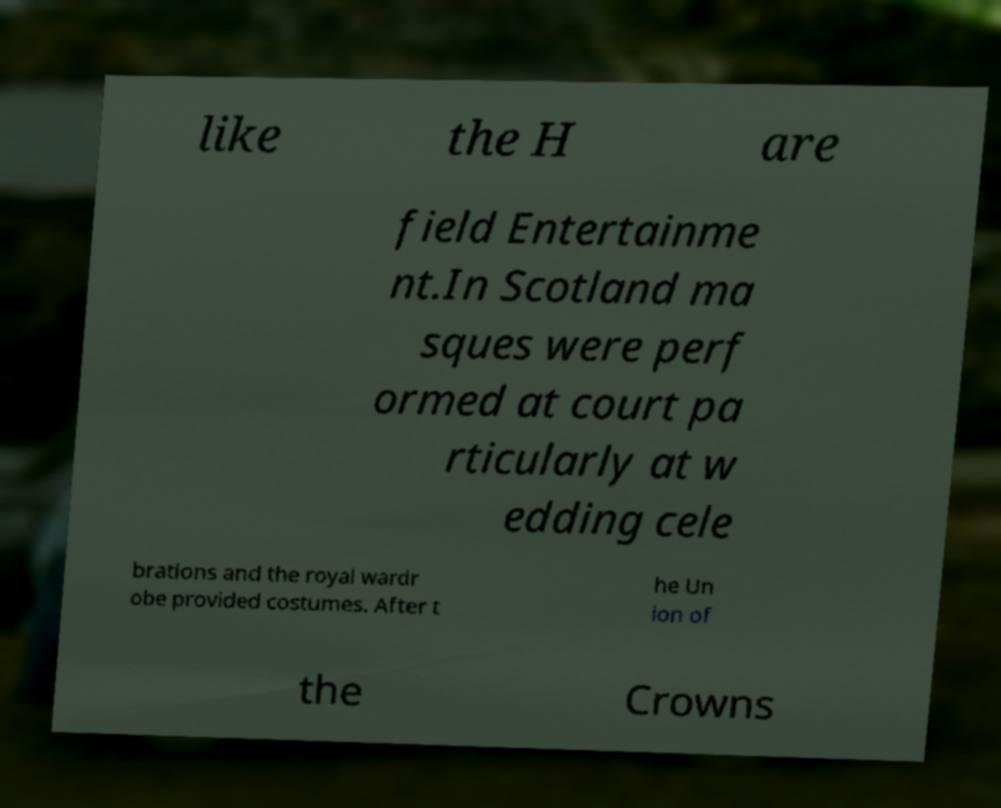There's text embedded in this image that I need extracted. Can you transcribe it verbatim? like the H are field Entertainme nt.In Scotland ma sques were perf ormed at court pa rticularly at w edding cele brations and the royal wardr obe provided costumes. After t he Un ion of the Crowns 